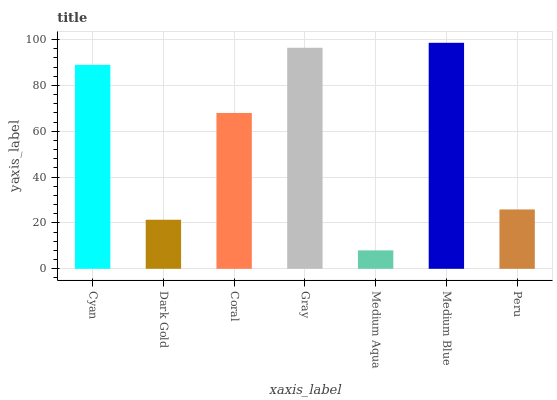Is Medium Aqua the minimum?
Answer yes or no. Yes. Is Medium Blue the maximum?
Answer yes or no. Yes. Is Dark Gold the minimum?
Answer yes or no. No. Is Dark Gold the maximum?
Answer yes or no. No. Is Cyan greater than Dark Gold?
Answer yes or no. Yes. Is Dark Gold less than Cyan?
Answer yes or no. Yes. Is Dark Gold greater than Cyan?
Answer yes or no. No. Is Cyan less than Dark Gold?
Answer yes or no. No. Is Coral the high median?
Answer yes or no. Yes. Is Coral the low median?
Answer yes or no. Yes. Is Dark Gold the high median?
Answer yes or no. No. Is Medium Blue the low median?
Answer yes or no. No. 